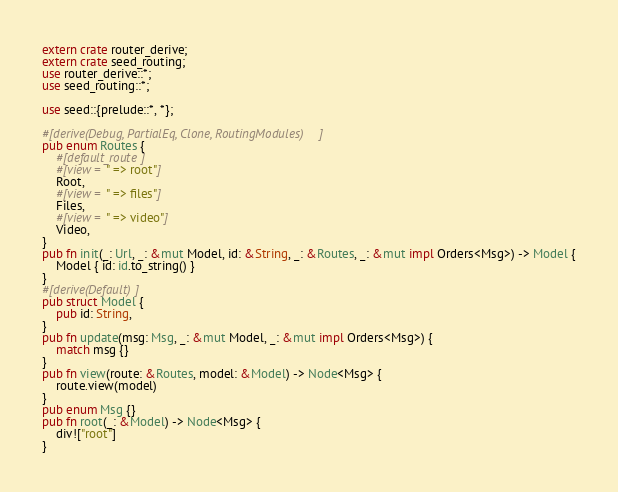<code> <loc_0><loc_0><loc_500><loc_500><_Rust_>extern crate router_derive;
extern crate seed_routing;
use router_derive::*;
use seed_routing::*;

use seed::{prelude::*, *};

#[derive(Debug, PartialEq, Clone, RoutingModules)]
pub enum Routes {
    #[default_route]
    #[view = " => root"]
    Root,
    #[view = " => files"]
    Files,
    #[view = " => video"]
    Video,
}
pub fn init(_: Url, _: &mut Model, id: &String, _: &Routes, _: &mut impl Orders<Msg>) -> Model {
    Model { id: id.to_string() }
}
#[derive(Default)]
pub struct Model {
    pub id: String,
}
pub fn update(msg: Msg, _: &mut Model, _: &mut impl Orders<Msg>) {
    match msg {}
}
pub fn view(route: &Routes, model: &Model) -> Node<Msg> {
    route.view(model)
}
pub enum Msg {}
pub fn root(_: &Model) -> Node<Msg> {
    div!["root"]
}</code> 